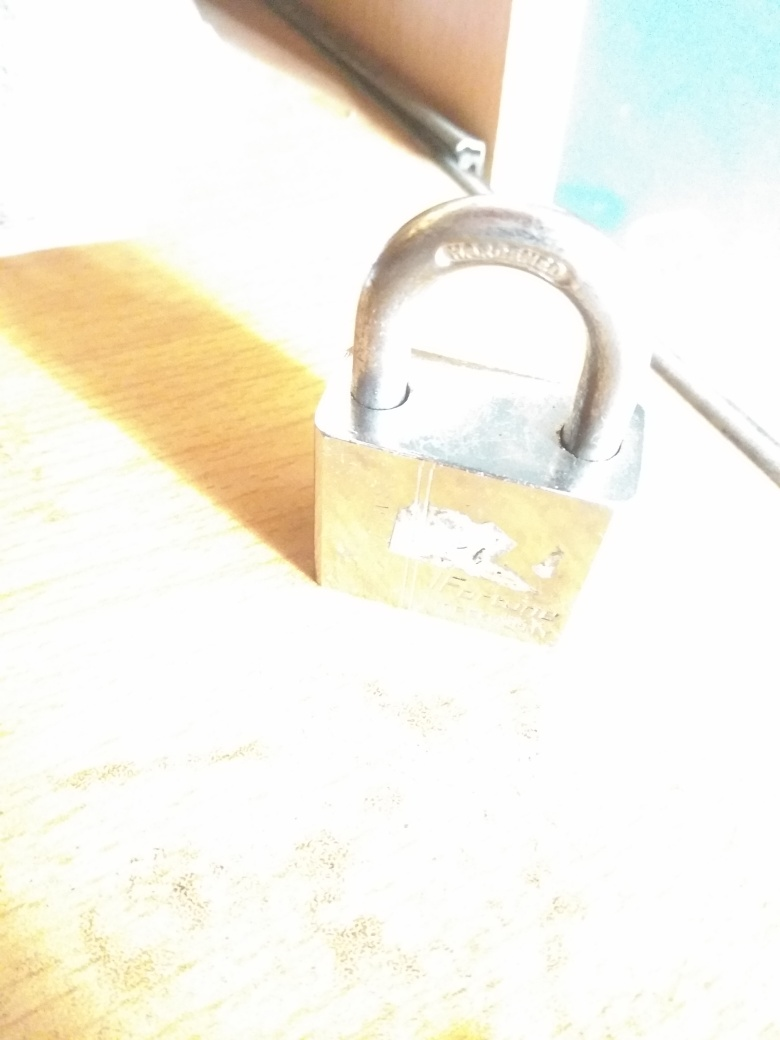What might be the purpose of photographing this object? While the intent is not clearly conveyed due to the quality of the photograph, it could be to document the object or its condition. However, the overexposure significantly detracts from the utility of the image for such purposes. How could the quality of this photograph be improved? To enhance the photo's quality, one could adjust the exposure to ensure the lighting is more balanced and does not overwhelm the subject. Ensuring the camera is stable, using a lower ISO setting, and perhaps choosing a different angle that minimizes direct light on the subject could result in a clearer and more detailed image. 